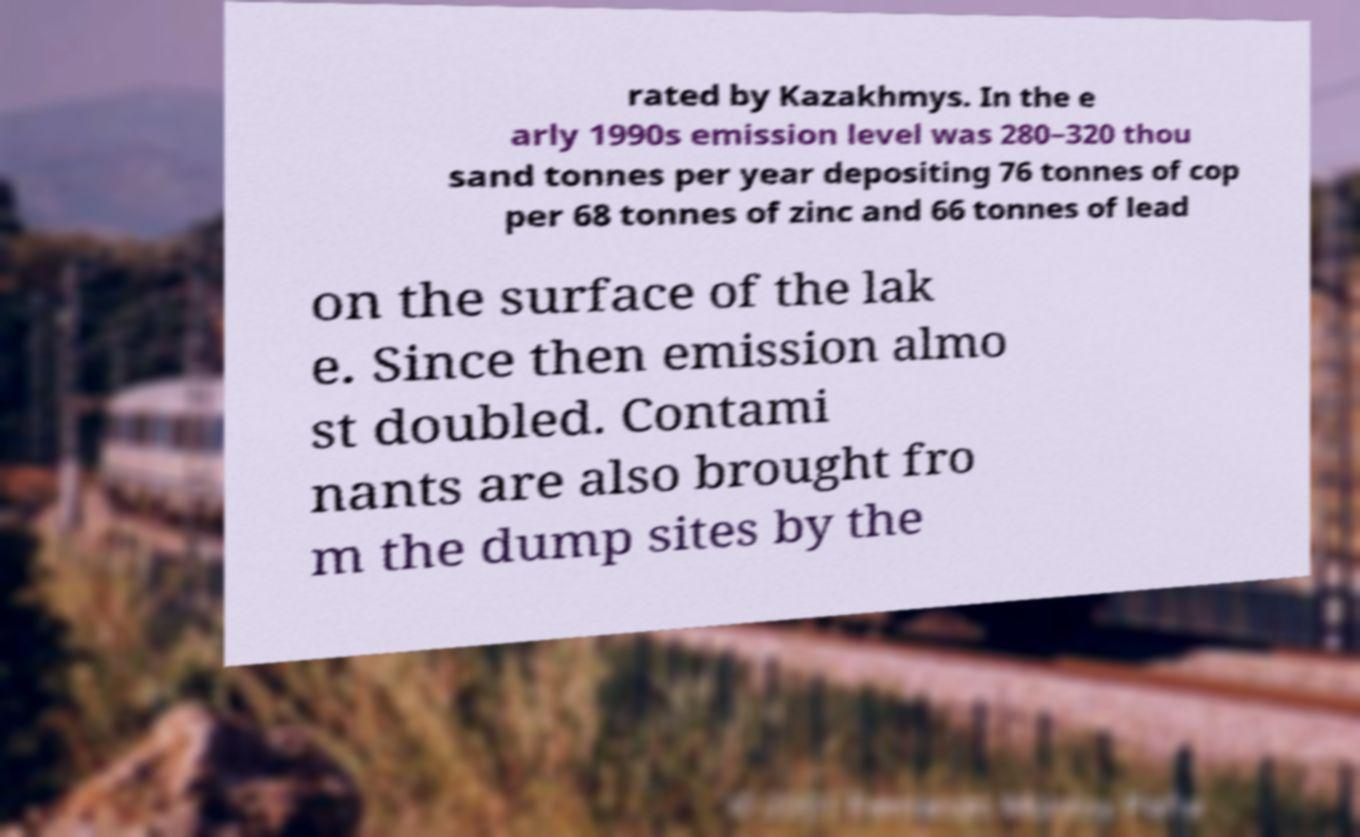Can you accurately transcribe the text from the provided image for me? rated by Kazakhmys. In the e arly 1990s emission level was 280–320 thou sand tonnes per year depositing 76 tonnes of cop per 68 tonnes of zinc and 66 tonnes of lead on the surface of the lak e. Since then emission almo st doubled. Contami nants are also brought fro m the dump sites by the 